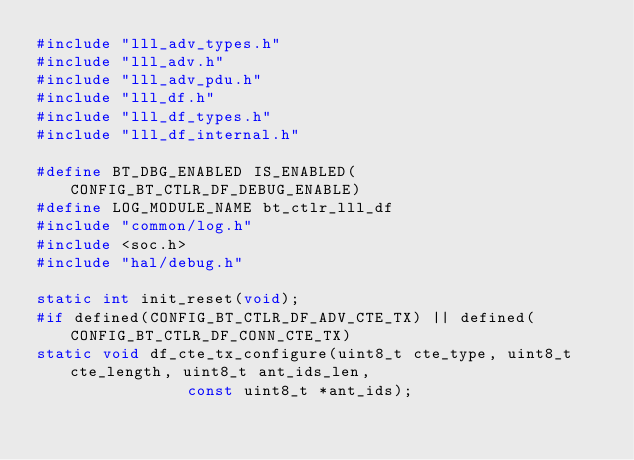<code> <loc_0><loc_0><loc_500><loc_500><_C_>#include "lll_adv_types.h"
#include "lll_adv.h"
#include "lll_adv_pdu.h"
#include "lll_df.h"
#include "lll_df_types.h"
#include "lll_df_internal.h"

#define BT_DBG_ENABLED IS_ENABLED(CONFIG_BT_CTLR_DF_DEBUG_ENABLE)
#define LOG_MODULE_NAME bt_ctlr_lll_df
#include "common/log.h"
#include <soc.h>
#include "hal/debug.h"

static int init_reset(void);
#if defined(CONFIG_BT_CTLR_DF_ADV_CTE_TX) || defined(CONFIG_BT_CTLR_DF_CONN_CTE_TX)
static void df_cte_tx_configure(uint8_t cte_type, uint8_t cte_length, uint8_t ant_ids_len,
				const uint8_t *ant_ids);</code> 